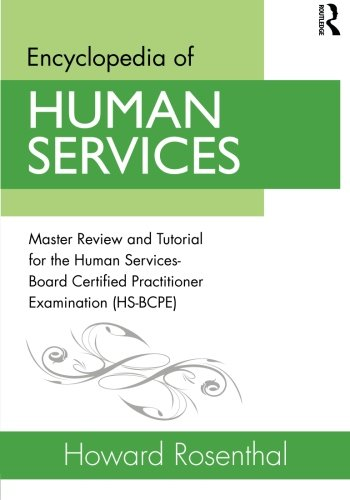Can you tell me who might find this book useful? This book would be incredibly useful for students, practitioners, and professionals in the field of human services, particularly those preparing for the Human Services-Board Certified Practitioner Examination. 